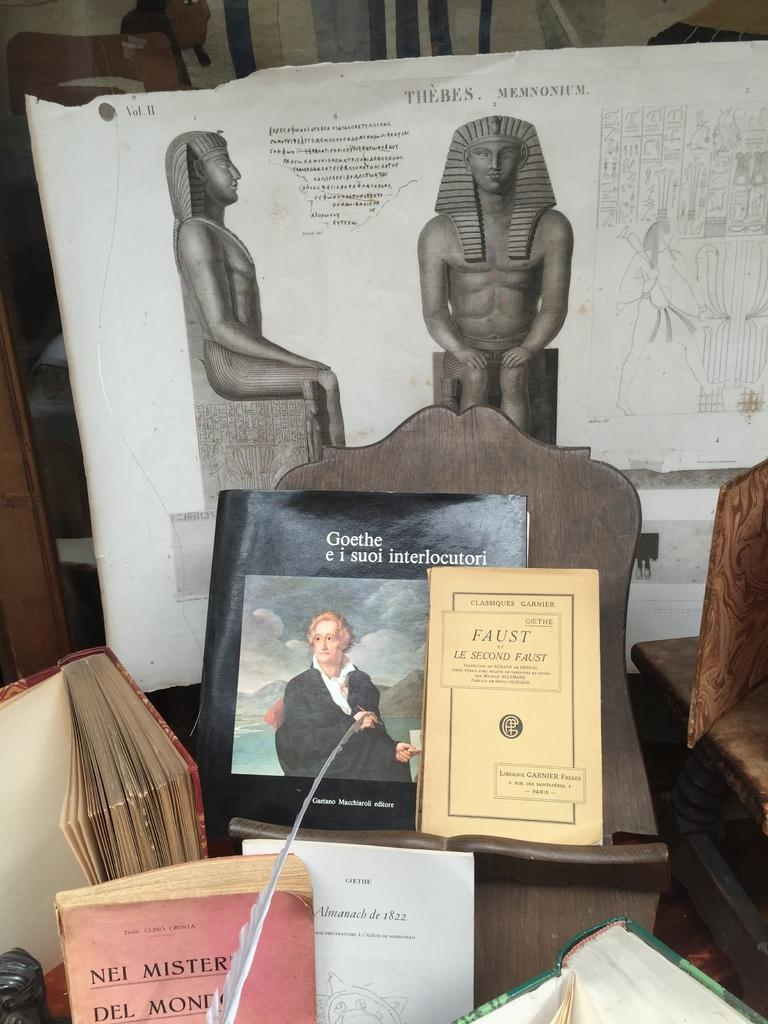Provide a one-sentence caption for the provided image. display of several books including faust, nei mister, and goethe e i suoi interlocutori. 